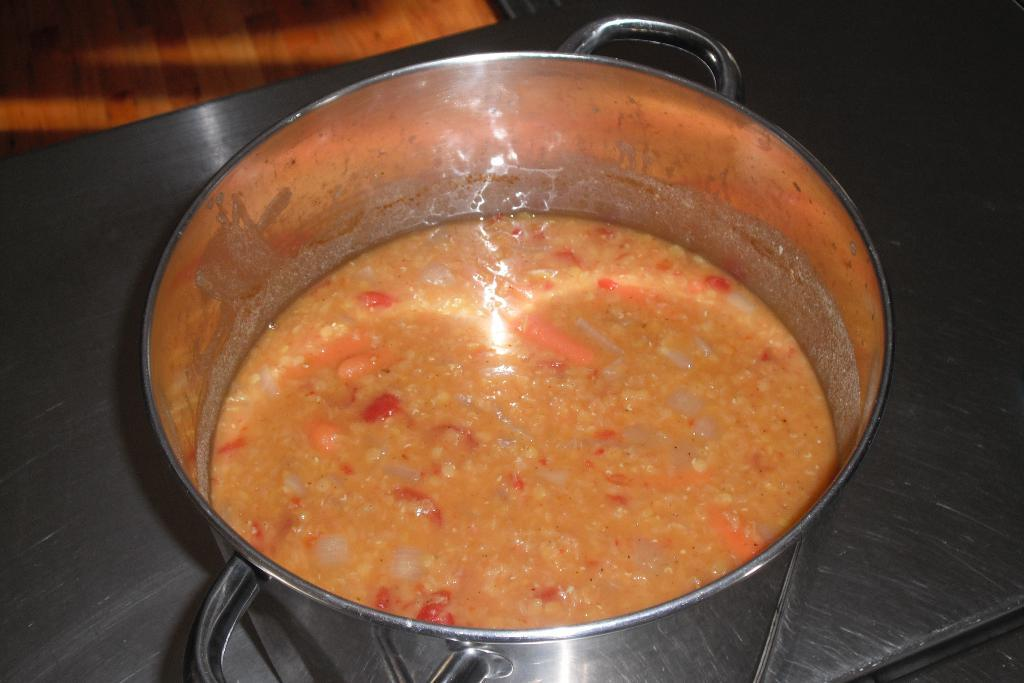What is on the table in the image? There is a utensil on the table in the image. What is inside the utensil? There is food in the utensil. Can you describe the floor in the image? The top left part of the image shows a wooden floor. Is there a flame coming from the pipe in the image? There is no pipe or flame present in the image. Are the police visible in the image? There is no reference to the police in the image. 